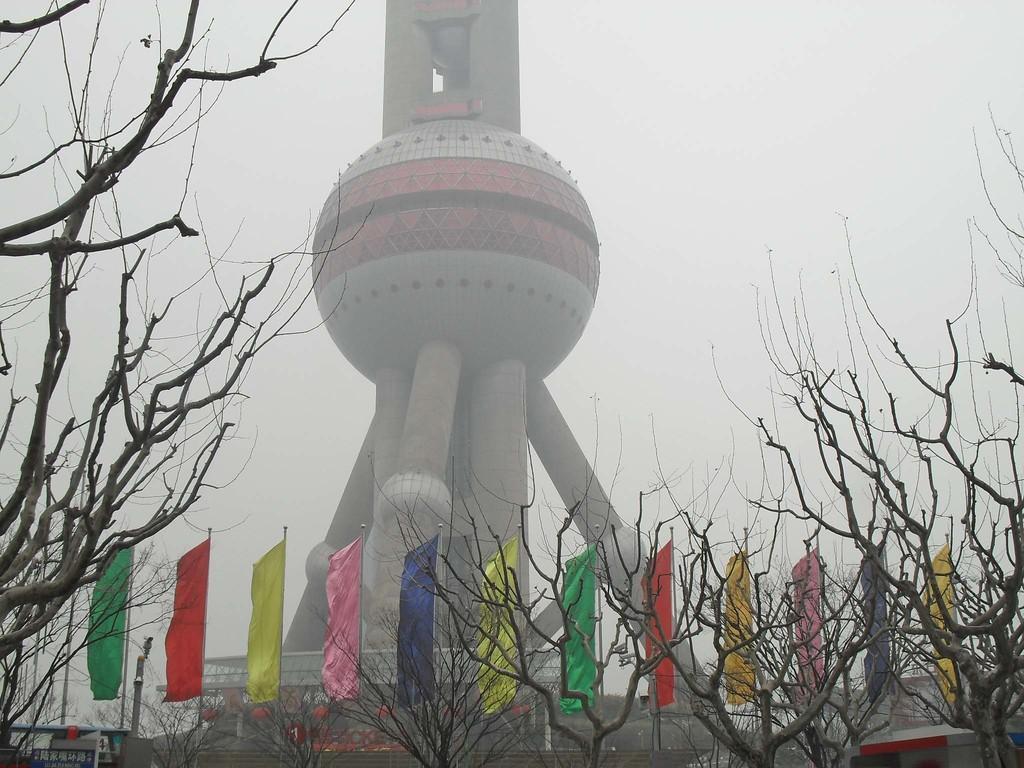Can you describe this image briefly? In this image we can see a tower. We can also see the flags to the poles, a group of trees, buildings, some poles and the sky which looks cloudy. 